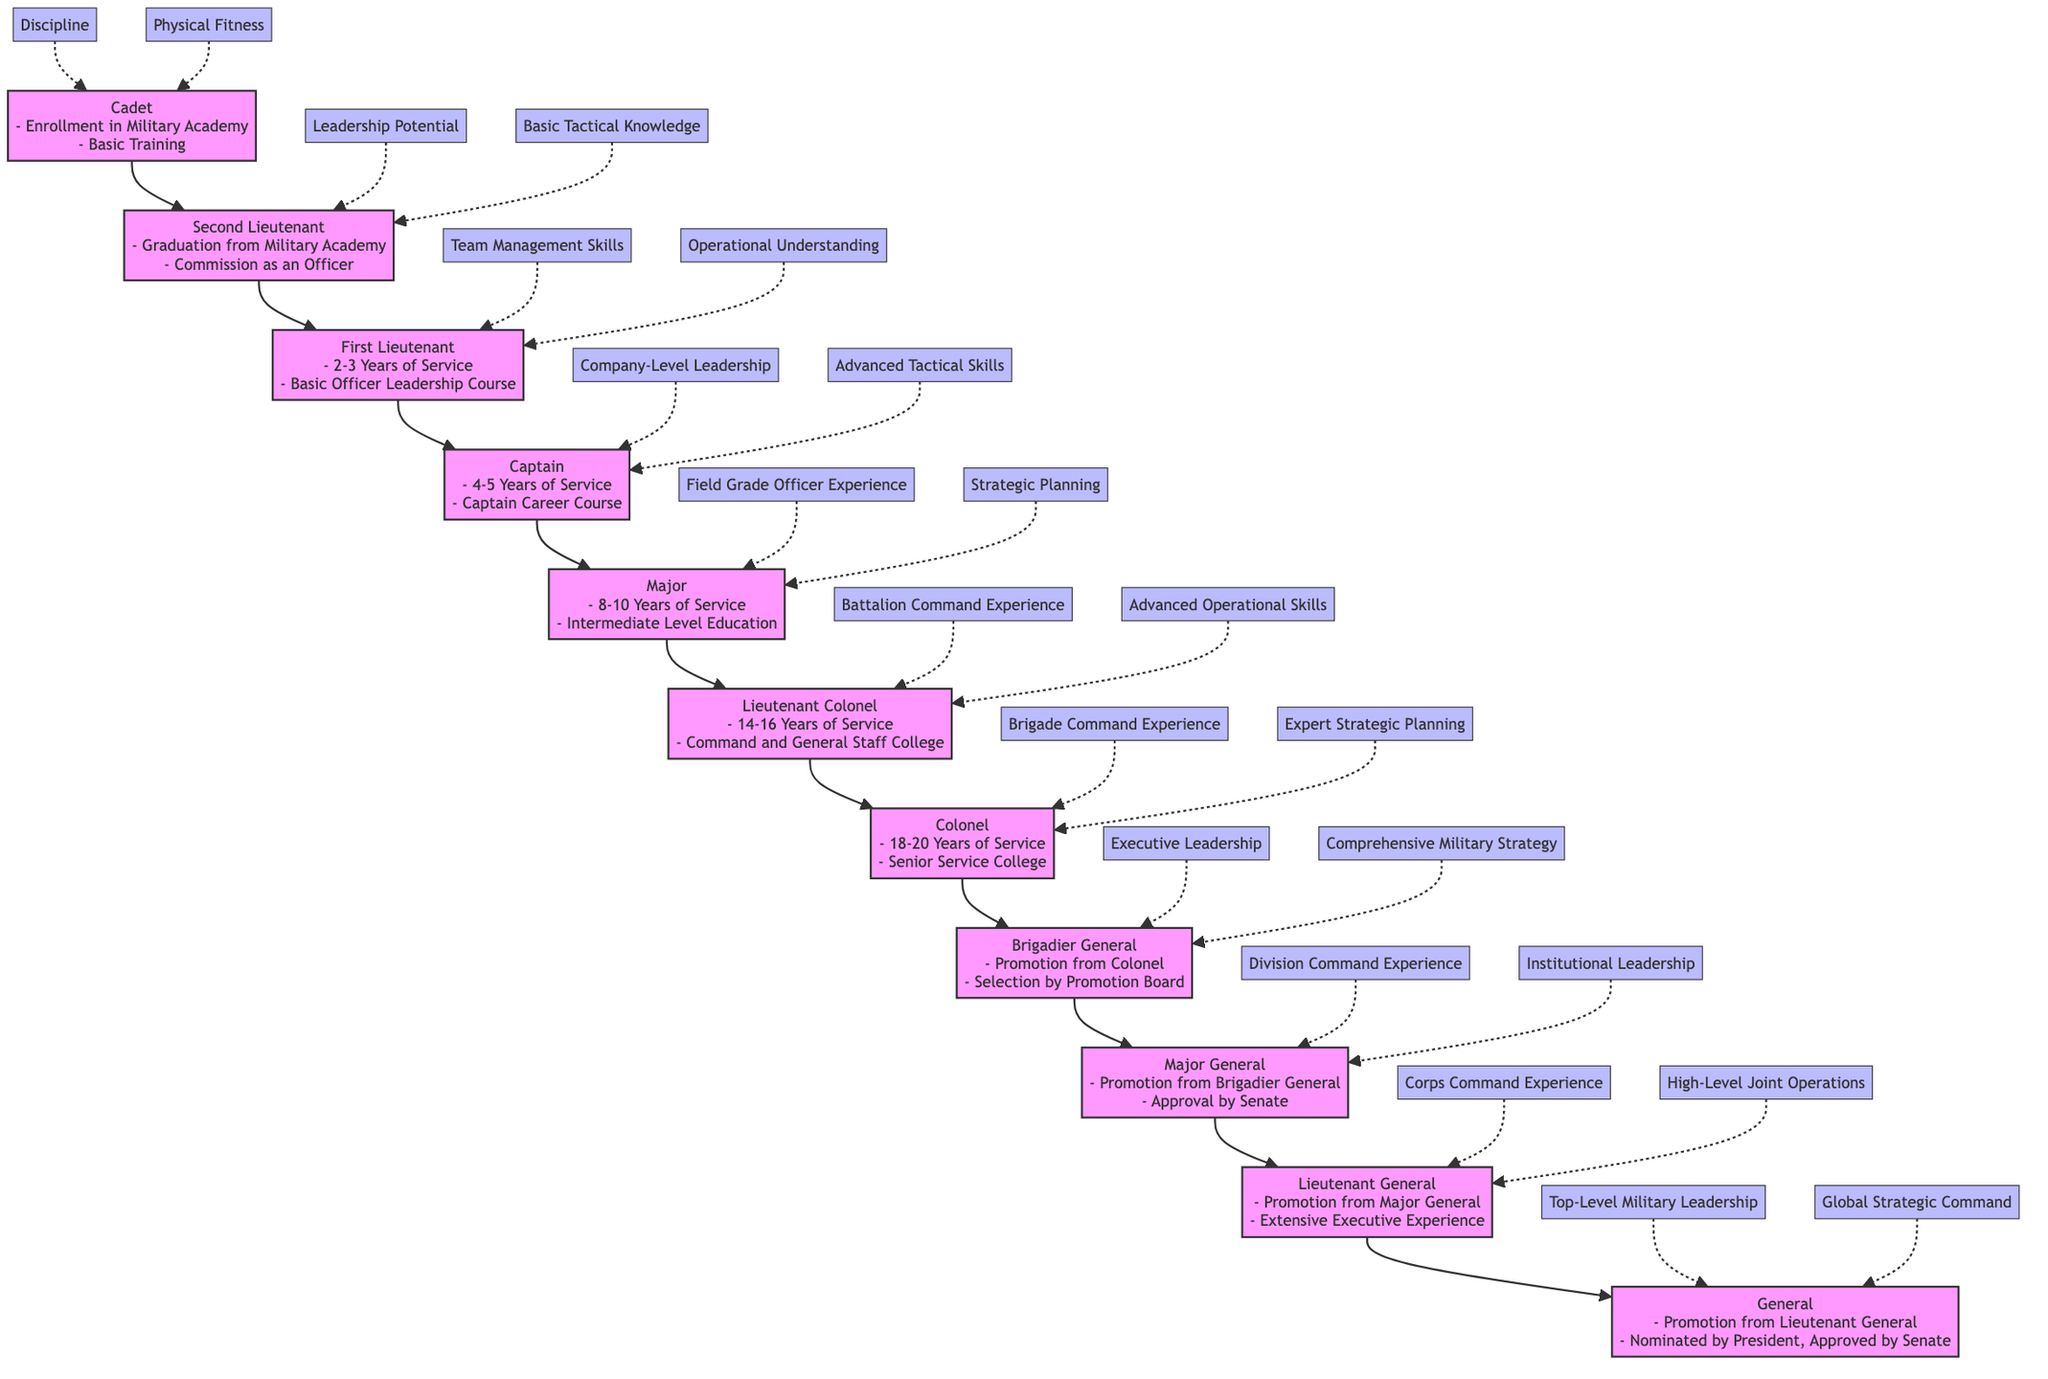What is the first level in the career progression? The first level in the diagram is indicated at the bottom, which is "Cadet." This can be identified by looking for the node that does not have any arrows directed towards it.
Answer: Cadet How many total levels are there in the career progression from Cadet to General? To find the number of levels, count each node listed in the flow diagram from Cadet to General. There are 11 nodes, each representing a level.
Answer: 11 What is the requirement to become a Major? The requirements for becoming a Major are listed at the node level for Major. They state "8-10 Years of Service" and "Completion of Intermediate Level Education." These requirements can be identified directly under the Major node.
Answer: 8-10 Years of Service, Completion of Intermediate Level Education Which rank requires "Approval by Senate"? The rank associated with the requirement "Approval by Senate" is Major General. This can be identified by looking for the node explicitly mentioning this requirement in its list.
Answer: Major General What is a common attribute of the Lieutenant Colonel rank? The attributes associated with the Lieutenant Colonel rank are specified in the diagram, which include "Battalion Command Experience" and "Advanced Operational Skills." This information can be found directly adjacent to the Lieutenant Colonel node.
Answer: Battalion Command Experience What is the rank directly above Captain? To determine the rank directly above Captain, look at the arrow pointing upwards from the Captain node, which leads to the next node indicating the rank of First Lieutenant.
Answer: First Lieutenant How many years of service are required to qualify as a Colonel? The requirement listed in the Colonel node indicates "18-20 Years of Service." This value can be found directly in the requirements section of the Colonel node.
Answer: 18-20 Years of Service What attribute is associated with the General rank? The attributes listed for the General rank include "Top-Level Military Leadership" and "Global Strategic Command." This information can be found correlated with the General node.
Answer: Top-Level Military Leadership What is the prerequisite for being promoted to Brigadier General? The prerequisites for being promoted to Brigadier General noted in the diagram are "Promotion from Colonel" and "Selection by Promotion Board." This can be confirmed by examining the requirements listed under the Brigadier General node.
Answer: Promotion from Colonel Which position is characterized by "Corps Command Experience"? Looking at the diagram, the position characterized by "Corps Command Experience" is the Lieutenant General. This can be seen directly next to the Lieutenant General node.
Answer: Lieutenant General 